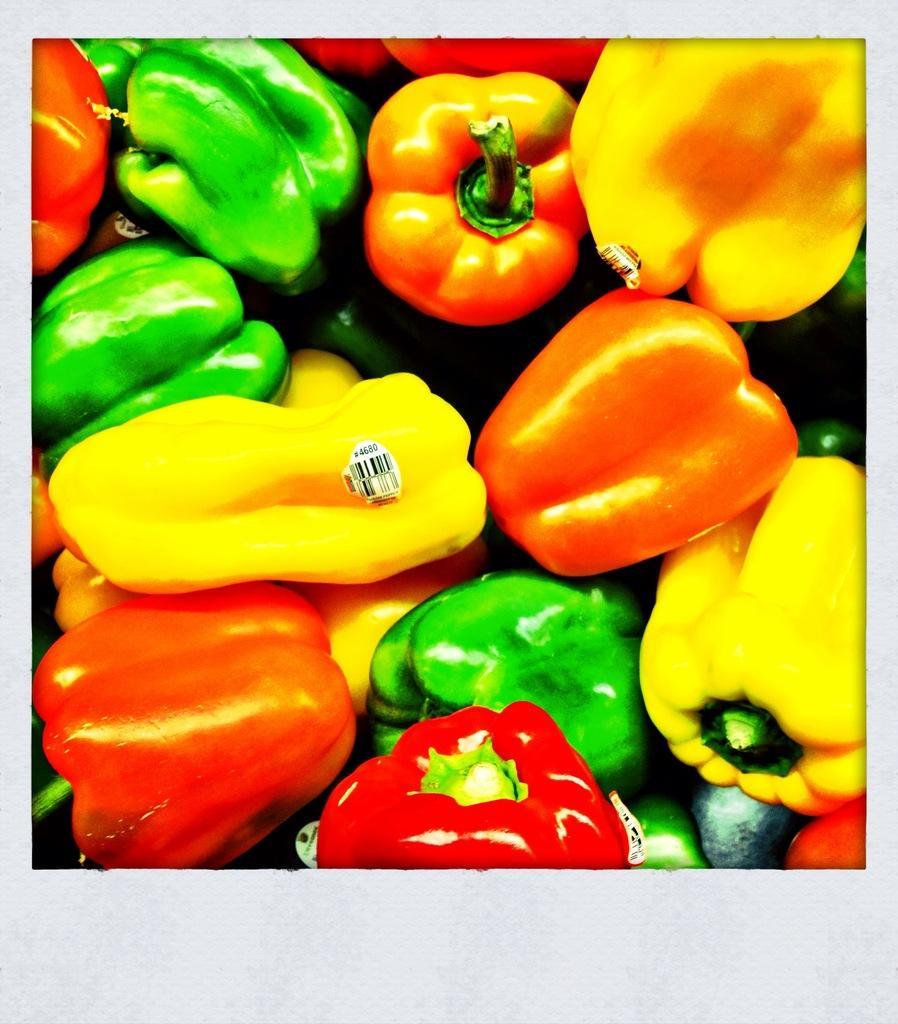Can you describe this image briefly? In this image there are capsicums of different colors. Middle of the image there is a capsicum having a label attached to it. 